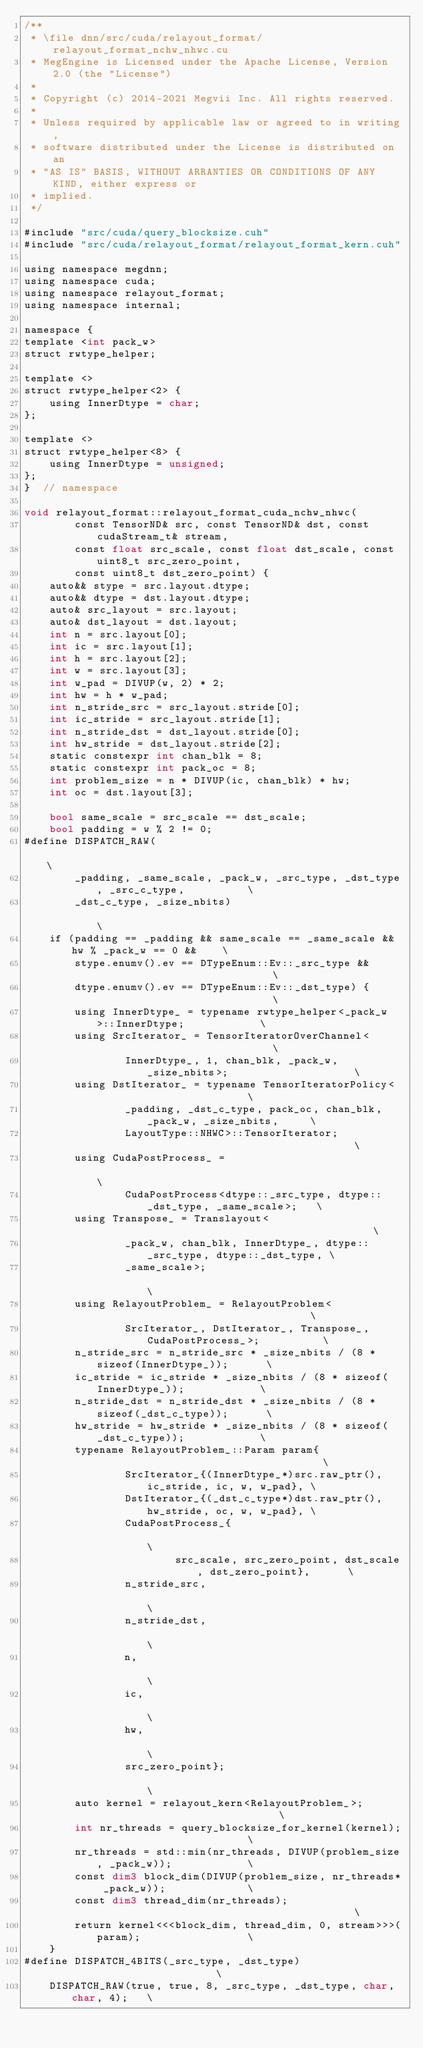Convert code to text. <code><loc_0><loc_0><loc_500><loc_500><_Cuda_>/**
 * \file dnn/src/cuda/relayout_format/relayout_format_nchw_nhwc.cu
 * MegEngine is Licensed under the Apache License, Version 2.0 (the "License")
 *
 * Copyright (c) 2014-2021 Megvii Inc. All rights reserved.
 *
 * Unless required by applicable law or agreed to in writing,
 * software distributed under the License is distributed on an
 * "AS IS" BASIS, WITHOUT ARRANTIES OR CONDITIONS OF ANY KIND, either express or
 * implied.
 */

#include "src/cuda/query_blocksize.cuh"
#include "src/cuda/relayout_format/relayout_format_kern.cuh"

using namespace megdnn;
using namespace cuda;
using namespace relayout_format;
using namespace internal;

namespace {
template <int pack_w>
struct rwtype_helper;

template <>
struct rwtype_helper<2> {
    using InnerDtype = char;
};

template <>
struct rwtype_helper<8> {
    using InnerDtype = unsigned;
};
}  // namespace

void relayout_format::relayout_format_cuda_nchw_nhwc(
        const TensorND& src, const TensorND& dst, const cudaStream_t& stream,
        const float src_scale, const float dst_scale, const uint8_t src_zero_point,
        const uint8_t dst_zero_point) {
    auto&& stype = src.layout.dtype;
    auto&& dtype = dst.layout.dtype;
    auto& src_layout = src.layout;
    auto& dst_layout = dst.layout;
    int n = src.layout[0];
    int ic = src.layout[1];
    int h = src.layout[2];
    int w = src.layout[3];
    int w_pad = DIVUP(w, 2) * 2;
    int hw = h * w_pad;
    int n_stride_src = src_layout.stride[0];
    int ic_stride = src_layout.stride[1];
    int n_stride_dst = dst_layout.stride[0];
    int hw_stride = dst_layout.stride[2];
    static constexpr int chan_blk = 8;
    static constexpr int pack_oc = 8;
    int problem_size = n * DIVUP(ic, chan_blk) * hw;
    int oc = dst.layout[3];

    bool same_scale = src_scale == dst_scale;
    bool padding = w % 2 != 0;
#define DISPATCH_RAW(                                                               \
        _padding, _same_scale, _pack_w, _src_type, _dst_type, _src_c_type,          \
        _dst_c_type, _size_nbits)                                                   \
    if (padding == _padding && same_scale == _same_scale && hw % _pack_w == 0 &&    \
        stype.enumv().ev == DTypeEnum::Ev::_src_type &&                             \
        dtype.enumv().ev == DTypeEnum::Ev::_dst_type) {                             \
        using InnerDtype_ = typename rwtype_helper<_pack_w>::InnerDtype;            \
        using SrcIterator_ = TensorIteratorOverChannel<                             \
                InnerDtype_, 1, chan_blk, _pack_w, _size_nbits>;                    \
        using DstIterator_ = typename TensorIteratorPolicy<                         \
                _padding, _dst_c_type, pack_oc, chan_blk, _pack_w, _size_nbits,     \
                LayoutType::NHWC>::TensorIterator;                                  \
        using CudaPostProcess_ =                                                    \
                CudaPostProcess<dtype::_src_type, dtype::_dst_type, _same_scale>;   \
        using Transpose_ = Translayout<                                             \
                _pack_w, chan_blk, InnerDtype_, dtype::_src_type, dtype::_dst_type, \
                _same_scale>;                                                       \
        using RelayoutProblem_ = RelayoutProblem<                                   \
                SrcIterator_, DstIterator_, Transpose_, CudaPostProcess_>;          \
        n_stride_src = n_stride_src * _size_nbits / (8 * sizeof(InnerDtype_));      \
        ic_stride = ic_stride * _size_nbits / (8 * sizeof(InnerDtype_));            \
        n_stride_dst = n_stride_dst * _size_nbits / (8 * sizeof(_dst_c_type));      \
        hw_stride = hw_stride * _size_nbits / (8 * sizeof(_dst_c_type));            \
        typename RelayoutProblem_::Param param{                                     \
                SrcIterator_{(InnerDtype_*)src.raw_ptr(), ic_stride, ic, w, w_pad}, \
                DstIterator_{(_dst_c_type*)dst.raw_ptr(), hw_stride, oc, w, w_pad}, \
                CudaPostProcess_{                                                   \
                        src_scale, src_zero_point, dst_scale, dst_zero_point},      \
                n_stride_src,                                                       \
                n_stride_dst,                                                       \
                n,                                                                  \
                ic,                                                                 \
                hw,                                                                 \
                src_zero_point};                                                    \
        auto kernel = relayout_kern<RelayoutProblem_>;                              \
        int nr_threads = query_blocksize_for_kernel(kernel);                        \
        nr_threads = std::min(nr_threads, DIVUP(problem_size, _pack_w));            \
        const dim3 block_dim(DIVUP(problem_size, nr_threads* _pack_w));             \
        const dim3 thread_dim(nr_threads);                                          \
        return kernel<<<block_dim, thread_dim, 0, stream>>>(param);                 \
    }
#define DISPATCH_4BITS(_src_type, _dst_type)                            \
    DISPATCH_RAW(true, true, 8, _src_type, _dst_type, char, char, 4);   \</code> 